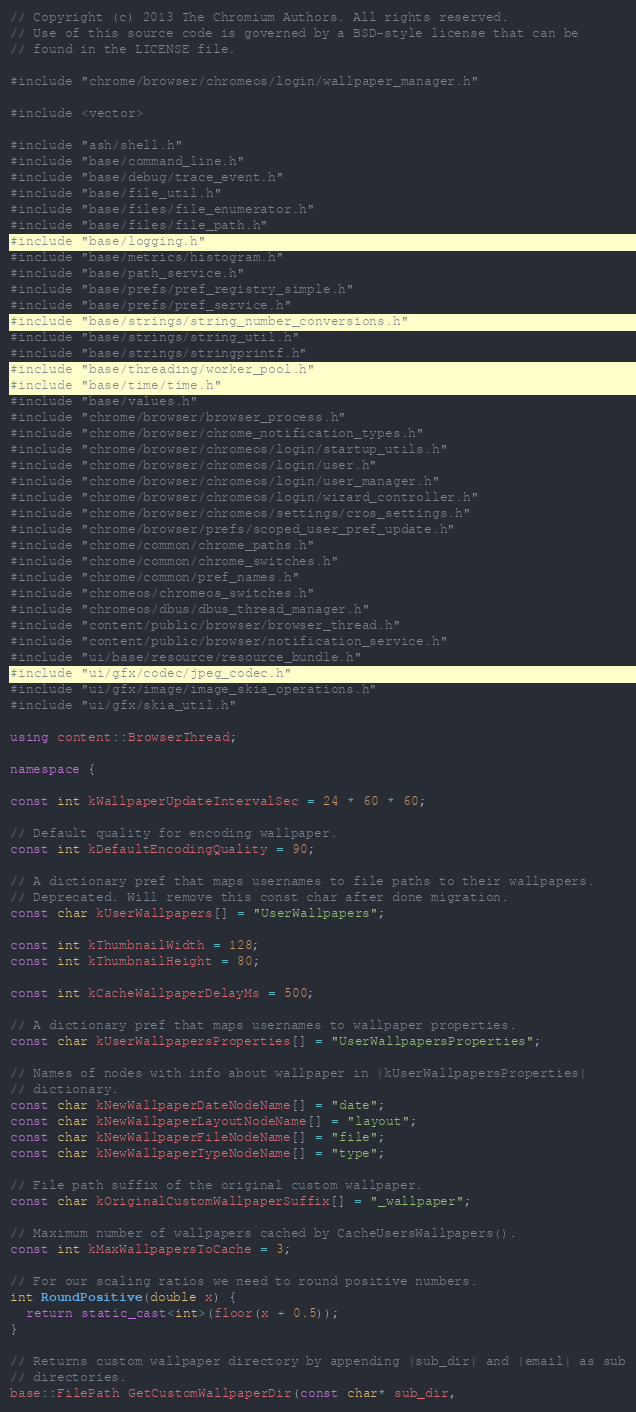Convert code to text. <code><loc_0><loc_0><loc_500><loc_500><_C++_>// Copyright (c) 2013 The Chromium Authors. All rights reserved.
// Use of this source code is governed by a BSD-style license that can be
// found in the LICENSE file.

#include "chrome/browser/chromeos/login/wallpaper_manager.h"

#include <vector>

#include "ash/shell.h"
#include "base/command_line.h"
#include "base/debug/trace_event.h"
#include "base/file_util.h"
#include "base/files/file_enumerator.h"
#include "base/files/file_path.h"
#include "base/logging.h"
#include "base/metrics/histogram.h"
#include "base/path_service.h"
#include "base/prefs/pref_registry_simple.h"
#include "base/prefs/pref_service.h"
#include "base/strings/string_number_conversions.h"
#include "base/strings/string_util.h"
#include "base/strings/stringprintf.h"
#include "base/threading/worker_pool.h"
#include "base/time/time.h"
#include "base/values.h"
#include "chrome/browser/browser_process.h"
#include "chrome/browser/chrome_notification_types.h"
#include "chrome/browser/chromeos/login/startup_utils.h"
#include "chrome/browser/chromeos/login/user.h"
#include "chrome/browser/chromeos/login/user_manager.h"
#include "chrome/browser/chromeos/login/wizard_controller.h"
#include "chrome/browser/chromeos/settings/cros_settings.h"
#include "chrome/browser/prefs/scoped_user_pref_update.h"
#include "chrome/common/chrome_paths.h"
#include "chrome/common/chrome_switches.h"
#include "chrome/common/pref_names.h"
#include "chromeos/chromeos_switches.h"
#include "chromeos/dbus/dbus_thread_manager.h"
#include "content/public/browser/browser_thread.h"
#include "content/public/browser/notification_service.h"
#include "ui/base/resource/resource_bundle.h"
#include "ui/gfx/codec/jpeg_codec.h"
#include "ui/gfx/image/image_skia_operations.h"
#include "ui/gfx/skia_util.h"

using content::BrowserThread;

namespace {

const int kWallpaperUpdateIntervalSec = 24 * 60 * 60;

// Default quality for encoding wallpaper.
const int kDefaultEncodingQuality = 90;

// A dictionary pref that maps usernames to file paths to their wallpapers.
// Deprecated. Will remove this const char after done migration.
const char kUserWallpapers[] = "UserWallpapers";

const int kThumbnailWidth = 128;
const int kThumbnailHeight = 80;

const int kCacheWallpaperDelayMs = 500;

// A dictionary pref that maps usernames to wallpaper properties.
const char kUserWallpapersProperties[] = "UserWallpapersProperties";

// Names of nodes with info about wallpaper in |kUserWallpapersProperties|
// dictionary.
const char kNewWallpaperDateNodeName[] = "date";
const char kNewWallpaperLayoutNodeName[] = "layout";
const char kNewWallpaperFileNodeName[] = "file";
const char kNewWallpaperTypeNodeName[] = "type";

// File path suffix of the original custom wallpaper.
const char kOriginalCustomWallpaperSuffix[] = "_wallpaper";

// Maximum number of wallpapers cached by CacheUsersWallpapers().
const int kMaxWallpapersToCache = 3;

// For our scaling ratios we need to round positive numbers.
int RoundPositive(double x) {
  return static_cast<int>(floor(x + 0.5));
}

// Returns custom wallpaper directory by appending |sub_dir| and |email| as sub
// directories.
base::FilePath GetCustomWallpaperDir(const char* sub_dir,</code> 